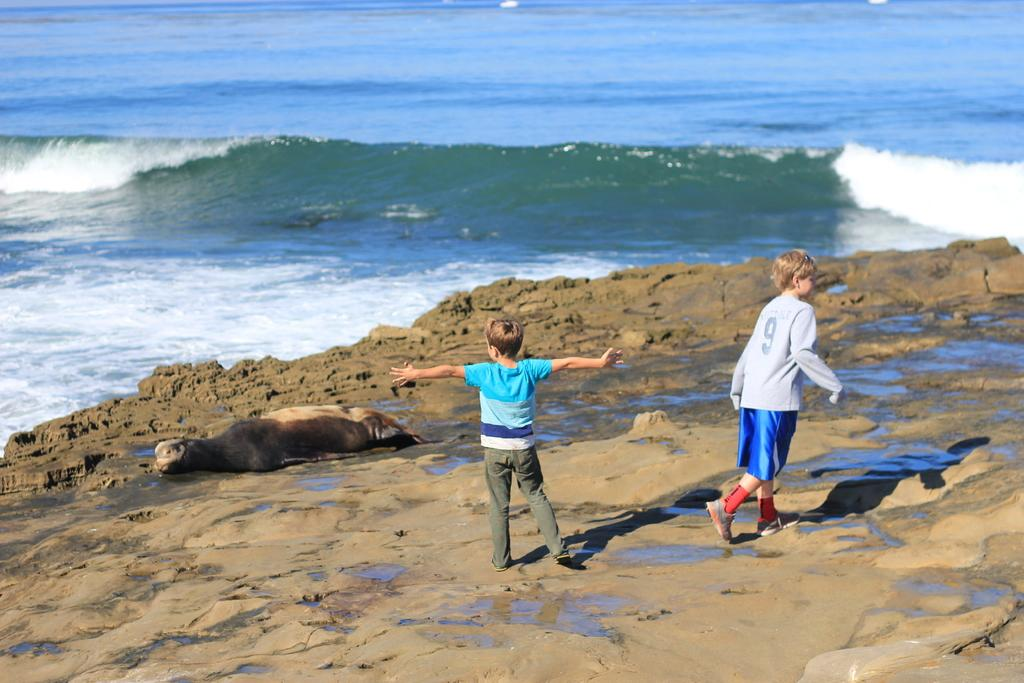What animal is present on the mud surface in the image? There is a seal on the mud surface in the image. What else can be seen on the mud surface? There are two boys on the mud surface. What is visible in the background of the image? The background of the image contains water. What type of curve can be seen in the image? There is no curve present in the image; it features a seal, two boys, and a background with water. What pet is visible in the image? There is no pet present in the image; it features a seal, two boys, and a background with water. 